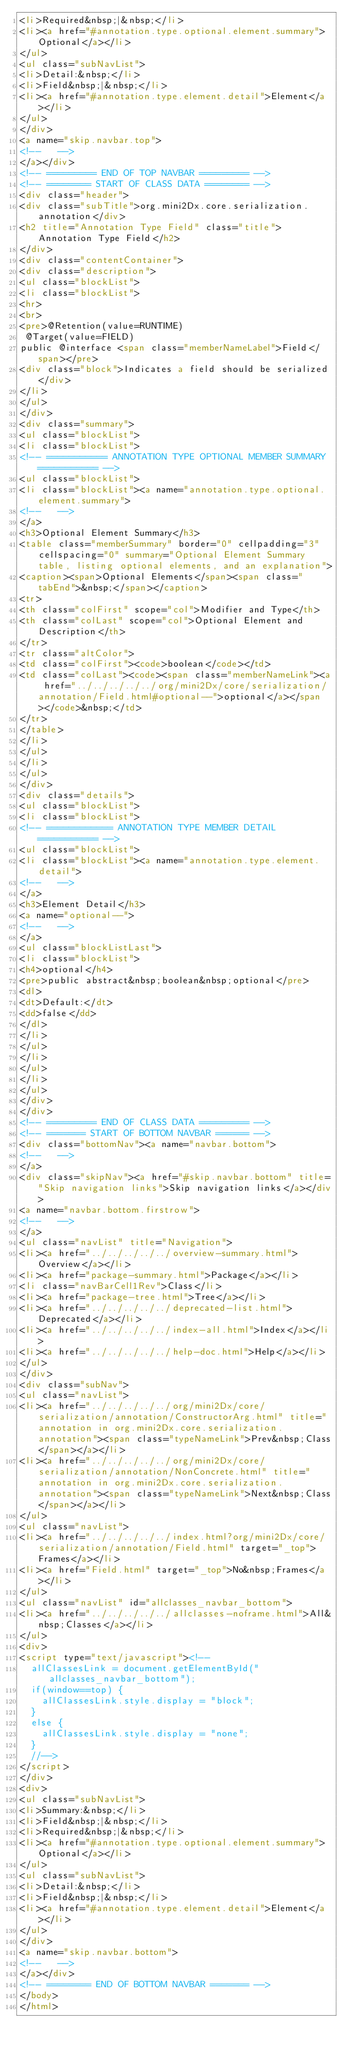<code> <loc_0><loc_0><loc_500><loc_500><_HTML_><li>Required&nbsp;|&nbsp;</li>
<li><a href="#annotation.type.optional.element.summary">Optional</a></li>
</ul>
<ul class="subNavList">
<li>Detail:&nbsp;</li>
<li>Field&nbsp;|&nbsp;</li>
<li><a href="#annotation.type.element.detail">Element</a></li>
</ul>
</div>
<a name="skip.navbar.top">
<!--   -->
</a></div>
<!-- ========= END OF TOP NAVBAR ========= -->
<!-- ======== START OF CLASS DATA ======== -->
<div class="header">
<div class="subTitle">org.mini2Dx.core.serialization.annotation</div>
<h2 title="Annotation Type Field" class="title">Annotation Type Field</h2>
</div>
<div class="contentContainer">
<div class="description">
<ul class="blockList">
<li class="blockList">
<hr>
<br>
<pre>@Retention(value=RUNTIME)
 @Target(value=FIELD)
public @interface <span class="memberNameLabel">Field</span></pre>
<div class="block">Indicates a field should be serialized</div>
</li>
</ul>
</div>
<div class="summary">
<ul class="blockList">
<li class="blockList">
<!-- =========== ANNOTATION TYPE OPTIONAL MEMBER SUMMARY =========== -->
<ul class="blockList">
<li class="blockList"><a name="annotation.type.optional.element.summary">
<!--   -->
</a>
<h3>Optional Element Summary</h3>
<table class="memberSummary" border="0" cellpadding="3" cellspacing="0" summary="Optional Element Summary table, listing optional elements, and an explanation">
<caption><span>Optional Elements</span><span class="tabEnd">&nbsp;</span></caption>
<tr>
<th class="colFirst" scope="col">Modifier and Type</th>
<th class="colLast" scope="col">Optional Element and Description</th>
</tr>
<tr class="altColor">
<td class="colFirst"><code>boolean</code></td>
<td class="colLast"><code><span class="memberNameLink"><a href="../../../../../org/mini2Dx/core/serialization/annotation/Field.html#optional--">optional</a></span></code>&nbsp;</td>
</tr>
</table>
</li>
</ul>
</li>
</ul>
</div>
<div class="details">
<ul class="blockList">
<li class="blockList">
<!-- ============ ANNOTATION TYPE MEMBER DETAIL =========== -->
<ul class="blockList">
<li class="blockList"><a name="annotation.type.element.detail">
<!--   -->
</a>
<h3>Element Detail</h3>
<a name="optional--">
<!--   -->
</a>
<ul class="blockListLast">
<li class="blockList">
<h4>optional</h4>
<pre>public abstract&nbsp;boolean&nbsp;optional</pre>
<dl>
<dt>Default:</dt>
<dd>false</dd>
</dl>
</li>
</ul>
</li>
</ul>
</li>
</ul>
</div>
</div>
<!-- ========= END OF CLASS DATA ========= -->
<!-- ======= START OF BOTTOM NAVBAR ====== -->
<div class="bottomNav"><a name="navbar.bottom">
<!--   -->
</a>
<div class="skipNav"><a href="#skip.navbar.bottom" title="Skip navigation links">Skip navigation links</a></div>
<a name="navbar.bottom.firstrow">
<!--   -->
</a>
<ul class="navList" title="Navigation">
<li><a href="../../../../../overview-summary.html">Overview</a></li>
<li><a href="package-summary.html">Package</a></li>
<li class="navBarCell1Rev">Class</li>
<li><a href="package-tree.html">Tree</a></li>
<li><a href="../../../../../deprecated-list.html">Deprecated</a></li>
<li><a href="../../../../../index-all.html">Index</a></li>
<li><a href="../../../../../help-doc.html">Help</a></li>
</ul>
</div>
<div class="subNav">
<ul class="navList">
<li><a href="../../../../../org/mini2Dx/core/serialization/annotation/ConstructorArg.html" title="annotation in org.mini2Dx.core.serialization.annotation"><span class="typeNameLink">Prev&nbsp;Class</span></a></li>
<li><a href="../../../../../org/mini2Dx/core/serialization/annotation/NonConcrete.html" title="annotation in org.mini2Dx.core.serialization.annotation"><span class="typeNameLink">Next&nbsp;Class</span></a></li>
</ul>
<ul class="navList">
<li><a href="../../../../../index.html?org/mini2Dx/core/serialization/annotation/Field.html" target="_top">Frames</a></li>
<li><a href="Field.html" target="_top">No&nbsp;Frames</a></li>
</ul>
<ul class="navList" id="allclasses_navbar_bottom">
<li><a href="../../../../../allclasses-noframe.html">All&nbsp;Classes</a></li>
</ul>
<div>
<script type="text/javascript"><!--
  allClassesLink = document.getElementById("allclasses_navbar_bottom");
  if(window==top) {
    allClassesLink.style.display = "block";
  }
  else {
    allClassesLink.style.display = "none";
  }
  //-->
</script>
</div>
<div>
<ul class="subNavList">
<li>Summary:&nbsp;</li>
<li>Field&nbsp;|&nbsp;</li>
<li>Required&nbsp;|&nbsp;</li>
<li><a href="#annotation.type.optional.element.summary">Optional</a></li>
</ul>
<ul class="subNavList">
<li>Detail:&nbsp;</li>
<li>Field&nbsp;|&nbsp;</li>
<li><a href="#annotation.type.element.detail">Element</a></li>
</ul>
</div>
<a name="skip.navbar.bottom">
<!--   -->
</a></div>
<!-- ======== END OF BOTTOM NAVBAR ======= -->
</body>
</html>
</code> 